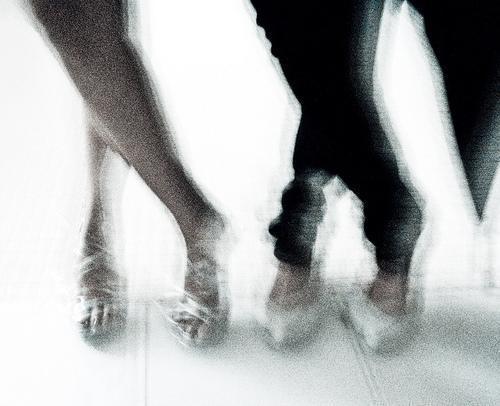How many people can you see?
Give a very brief answer. 2. 